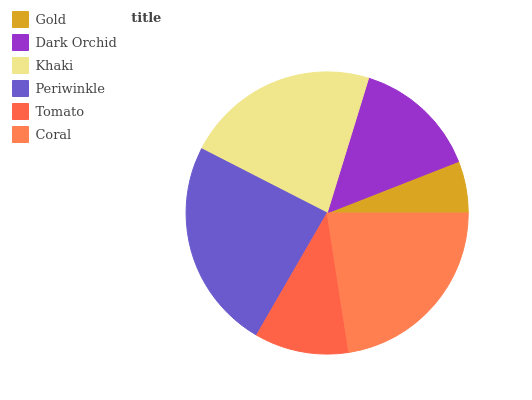Is Gold the minimum?
Answer yes or no. Yes. Is Periwinkle the maximum?
Answer yes or no. Yes. Is Dark Orchid the minimum?
Answer yes or no. No. Is Dark Orchid the maximum?
Answer yes or no. No. Is Dark Orchid greater than Gold?
Answer yes or no. Yes. Is Gold less than Dark Orchid?
Answer yes or no. Yes. Is Gold greater than Dark Orchid?
Answer yes or no. No. Is Dark Orchid less than Gold?
Answer yes or no. No. Is Khaki the high median?
Answer yes or no. Yes. Is Dark Orchid the low median?
Answer yes or no. Yes. Is Coral the high median?
Answer yes or no. No. Is Coral the low median?
Answer yes or no. No. 